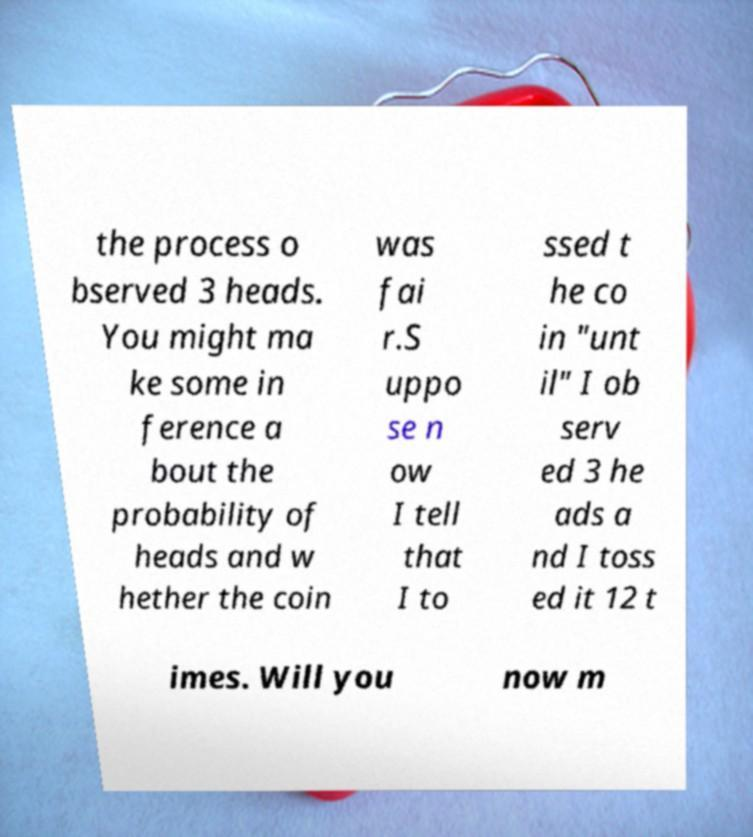Could you extract and type out the text from this image? the process o bserved 3 heads. You might ma ke some in ference a bout the probability of heads and w hether the coin was fai r.S uppo se n ow I tell that I to ssed t he co in "unt il" I ob serv ed 3 he ads a nd I toss ed it 12 t imes. Will you now m 